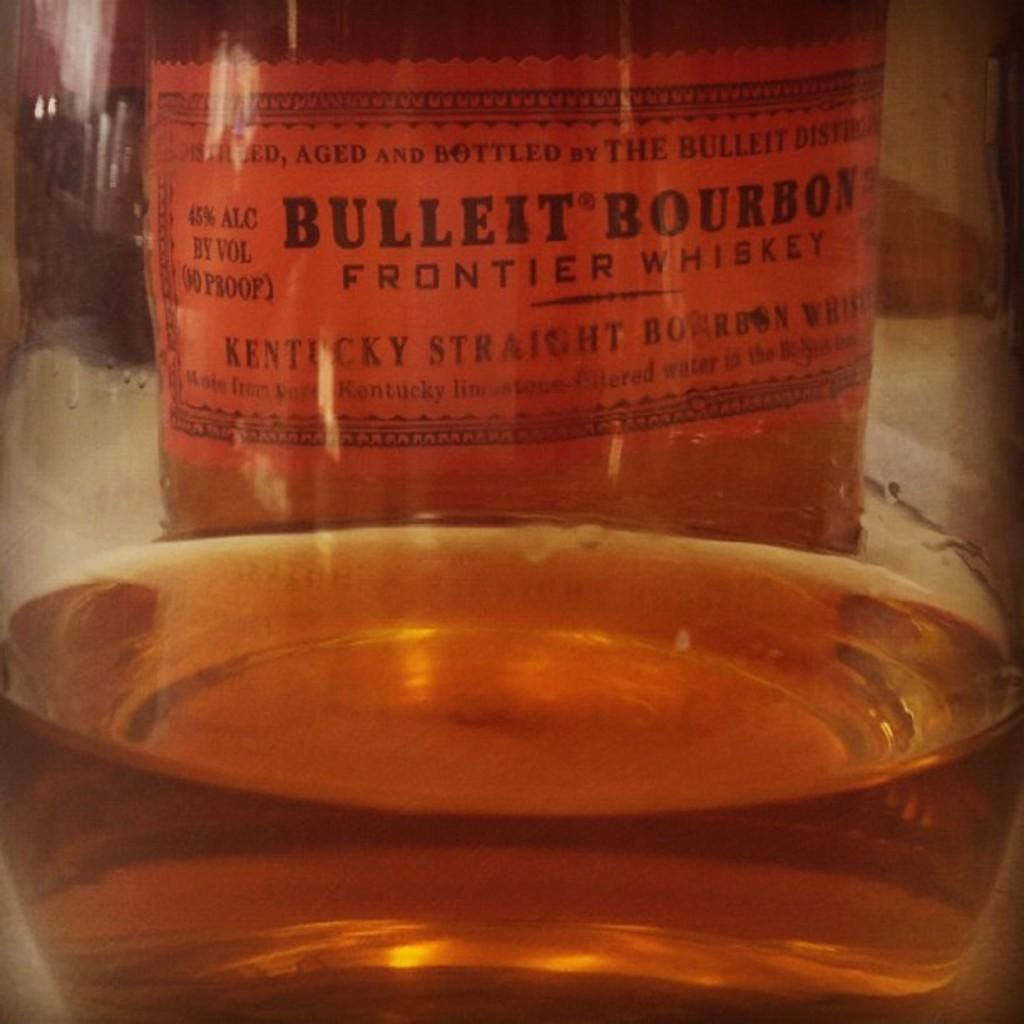Provide a one-sentence caption for the provided image. Bulleit Bourbon Frontier Whiskey is made with Kentucky bourbon. 